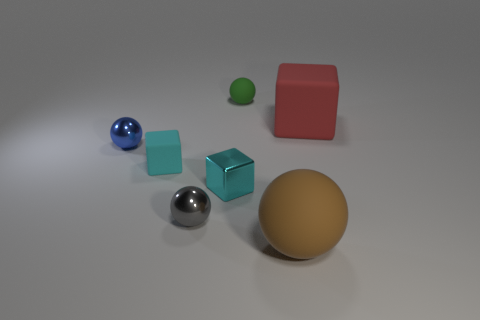Subtract all brown spheres. How many spheres are left? 3 Subtract all gray balls. How many balls are left? 3 Subtract all yellow balls. Subtract all purple blocks. How many balls are left? 4 Add 3 metallic balls. How many objects exist? 10 Subtract all balls. How many objects are left? 3 Subtract 0 green cylinders. How many objects are left? 7 Subtract all green objects. Subtract all brown balls. How many objects are left? 5 Add 6 small cubes. How many small cubes are left? 8 Add 1 purple metallic objects. How many purple metallic objects exist? 1 